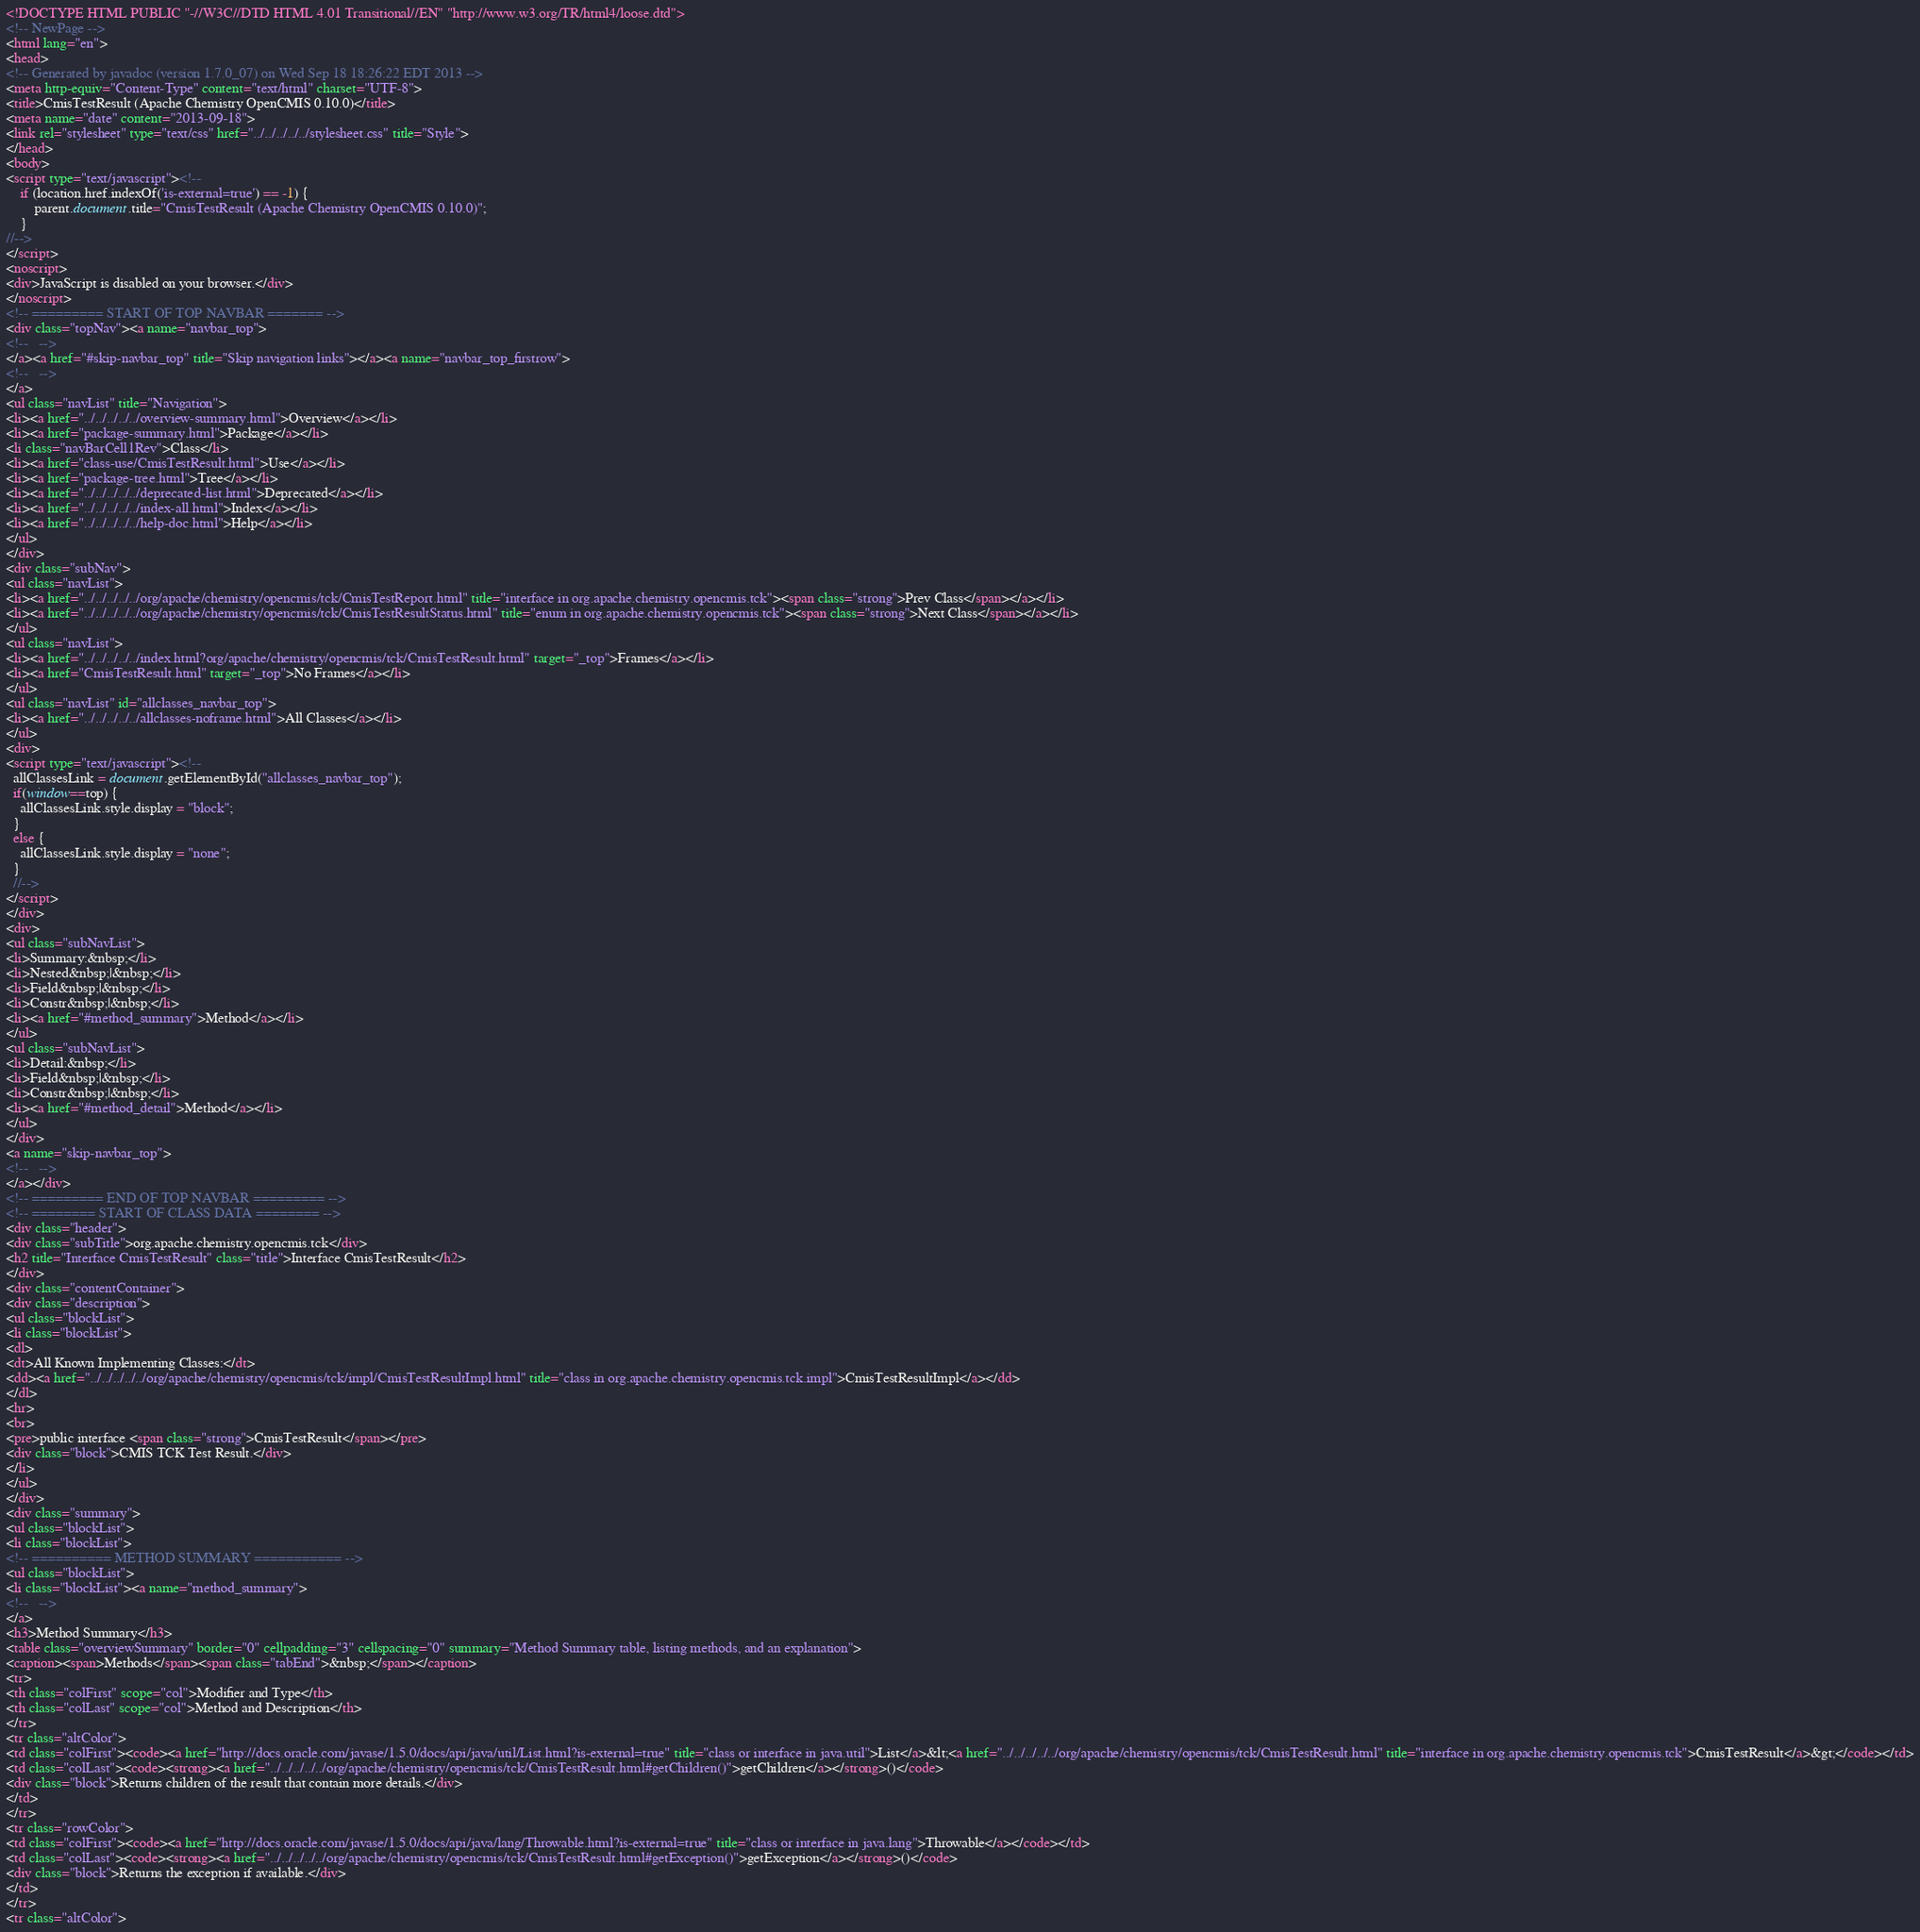Convert code to text. <code><loc_0><loc_0><loc_500><loc_500><_HTML_><!DOCTYPE HTML PUBLIC "-//W3C//DTD HTML 4.01 Transitional//EN" "http://www.w3.org/TR/html4/loose.dtd">
<!-- NewPage -->
<html lang="en">
<head>
<!-- Generated by javadoc (version 1.7.0_07) on Wed Sep 18 18:26:22 EDT 2013 -->
<meta http-equiv="Content-Type" content="text/html" charset="UTF-8">
<title>CmisTestResult (Apache Chemistry OpenCMIS 0.10.0)</title>
<meta name="date" content="2013-09-18">
<link rel="stylesheet" type="text/css" href="../../../../../stylesheet.css" title="Style">
</head>
<body>
<script type="text/javascript"><!--
    if (location.href.indexOf('is-external=true') == -1) {
        parent.document.title="CmisTestResult (Apache Chemistry OpenCMIS 0.10.0)";
    }
//-->
</script>
<noscript>
<div>JavaScript is disabled on your browser.</div>
</noscript>
<!-- ========= START OF TOP NAVBAR ======= -->
<div class="topNav"><a name="navbar_top">
<!--   -->
</a><a href="#skip-navbar_top" title="Skip navigation links"></a><a name="navbar_top_firstrow">
<!--   -->
</a>
<ul class="navList" title="Navigation">
<li><a href="../../../../../overview-summary.html">Overview</a></li>
<li><a href="package-summary.html">Package</a></li>
<li class="navBarCell1Rev">Class</li>
<li><a href="class-use/CmisTestResult.html">Use</a></li>
<li><a href="package-tree.html">Tree</a></li>
<li><a href="../../../../../deprecated-list.html">Deprecated</a></li>
<li><a href="../../../../../index-all.html">Index</a></li>
<li><a href="../../../../../help-doc.html">Help</a></li>
</ul>
</div>
<div class="subNav">
<ul class="navList">
<li><a href="../../../../../org/apache/chemistry/opencmis/tck/CmisTestReport.html" title="interface in org.apache.chemistry.opencmis.tck"><span class="strong">Prev Class</span></a></li>
<li><a href="../../../../../org/apache/chemistry/opencmis/tck/CmisTestResultStatus.html" title="enum in org.apache.chemistry.opencmis.tck"><span class="strong">Next Class</span></a></li>
</ul>
<ul class="navList">
<li><a href="../../../../../index.html?org/apache/chemistry/opencmis/tck/CmisTestResult.html" target="_top">Frames</a></li>
<li><a href="CmisTestResult.html" target="_top">No Frames</a></li>
</ul>
<ul class="navList" id="allclasses_navbar_top">
<li><a href="../../../../../allclasses-noframe.html">All Classes</a></li>
</ul>
<div>
<script type="text/javascript"><!--
  allClassesLink = document.getElementById("allclasses_navbar_top");
  if(window==top) {
    allClassesLink.style.display = "block";
  }
  else {
    allClassesLink.style.display = "none";
  }
  //-->
</script>
</div>
<div>
<ul class="subNavList">
<li>Summary:&nbsp;</li>
<li>Nested&nbsp;|&nbsp;</li>
<li>Field&nbsp;|&nbsp;</li>
<li>Constr&nbsp;|&nbsp;</li>
<li><a href="#method_summary">Method</a></li>
</ul>
<ul class="subNavList">
<li>Detail:&nbsp;</li>
<li>Field&nbsp;|&nbsp;</li>
<li>Constr&nbsp;|&nbsp;</li>
<li><a href="#method_detail">Method</a></li>
</ul>
</div>
<a name="skip-navbar_top">
<!--   -->
</a></div>
<!-- ========= END OF TOP NAVBAR ========= -->
<!-- ======== START OF CLASS DATA ======== -->
<div class="header">
<div class="subTitle">org.apache.chemistry.opencmis.tck</div>
<h2 title="Interface CmisTestResult" class="title">Interface CmisTestResult</h2>
</div>
<div class="contentContainer">
<div class="description">
<ul class="blockList">
<li class="blockList">
<dl>
<dt>All Known Implementing Classes:</dt>
<dd><a href="../../../../../org/apache/chemistry/opencmis/tck/impl/CmisTestResultImpl.html" title="class in org.apache.chemistry.opencmis.tck.impl">CmisTestResultImpl</a></dd>
</dl>
<hr>
<br>
<pre>public interface <span class="strong">CmisTestResult</span></pre>
<div class="block">CMIS TCK Test Result.</div>
</li>
</ul>
</div>
<div class="summary">
<ul class="blockList">
<li class="blockList">
<!-- ========== METHOD SUMMARY =========== -->
<ul class="blockList">
<li class="blockList"><a name="method_summary">
<!--   -->
</a>
<h3>Method Summary</h3>
<table class="overviewSummary" border="0" cellpadding="3" cellspacing="0" summary="Method Summary table, listing methods, and an explanation">
<caption><span>Methods</span><span class="tabEnd">&nbsp;</span></caption>
<tr>
<th class="colFirst" scope="col">Modifier and Type</th>
<th class="colLast" scope="col">Method and Description</th>
</tr>
<tr class="altColor">
<td class="colFirst"><code><a href="http://docs.oracle.com/javase/1.5.0/docs/api/java/util/List.html?is-external=true" title="class or interface in java.util">List</a>&lt;<a href="../../../../../org/apache/chemistry/opencmis/tck/CmisTestResult.html" title="interface in org.apache.chemistry.opencmis.tck">CmisTestResult</a>&gt;</code></td>
<td class="colLast"><code><strong><a href="../../../../../org/apache/chemistry/opencmis/tck/CmisTestResult.html#getChildren()">getChildren</a></strong>()</code>
<div class="block">Returns children of the result that contain more details.</div>
</td>
</tr>
<tr class="rowColor">
<td class="colFirst"><code><a href="http://docs.oracle.com/javase/1.5.0/docs/api/java/lang/Throwable.html?is-external=true" title="class or interface in java.lang">Throwable</a></code></td>
<td class="colLast"><code><strong><a href="../../../../../org/apache/chemistry/opencmis/tck/CmisTestResult.html#getException()">getException</a></strong>()</code>
<div class="block">Returns the exception if available.</div>
</td>
</tr>
<tr class="altColor"></code> 